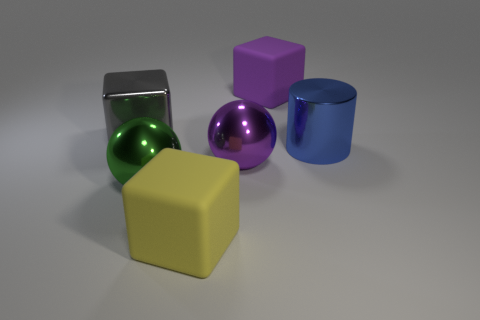What color is the other large rubber thing that is the same shape as the big yellow object?
Your response must be concise. Purple. What number of things are in front of the large blue object and to the left of the purple metal ball?
Make the answer very short. 2. Is the number of cubes that are in front of the purple matte thing greater than the number of rubber things behind the large green sphere?
Your answer should be compact. Yes. Are there any big purple matte objects of the same shape as the big gray thing?
Offer a terse response. Yes. There is a big yellow object; is it the same shape as the big gray metal object behind the large yellow rubber block?
Provide a succinct answer. Yes. What is the size of the cube that is both left of the purple matte thing and right of the green metallic ball?
Provide a succinct answer. Large. How many yellow rubber blocks are there?
Your answer should be compact. 1. There is a yellow object that is the same size as the cylinder; what is its material?
Your answer should be compact. Rubber. Are there any purple rubber spheres of the same size as the gray metallic thing?
Your answer should be compact. No. Do the big matte cube that is behind the gray block and the large metal sphere that is on the right side of the green sphere have the same color?
Provide a succinct answer. Yes. 